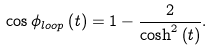<formula> <loc_0><loc_0><loc_500><loc_500>\cos \phi _ { l o o p } \left ( t \right ) = 1 - \frac { 2 } { \cosh ^ { 2 } \left ( t \right ) } .</formula> 